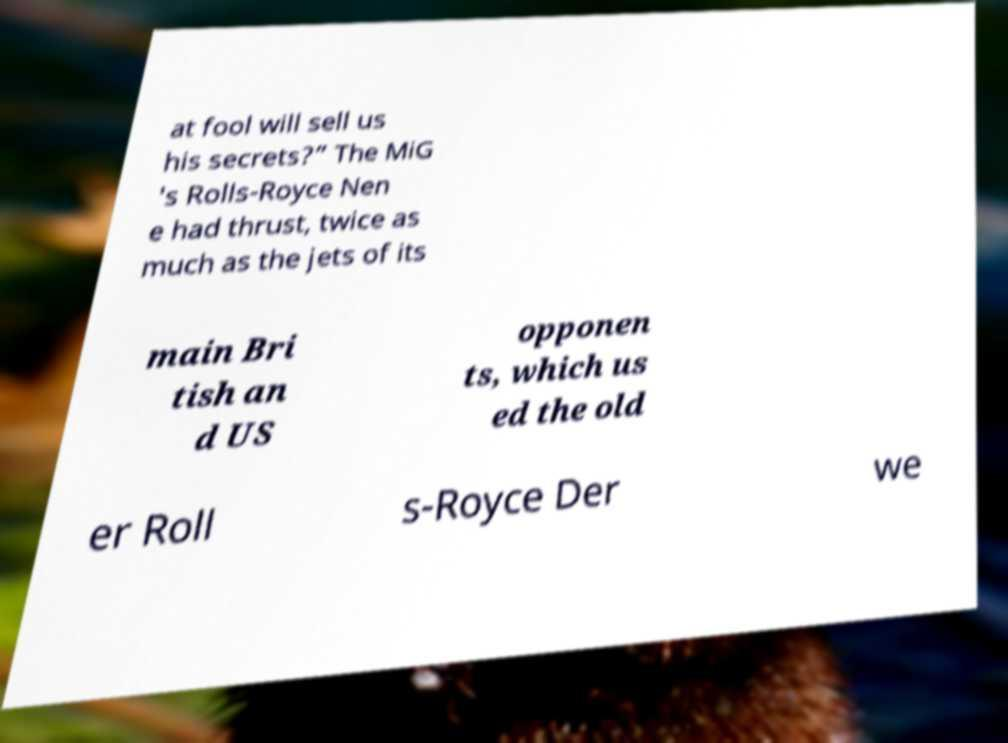Can you read and provide the text displayed in the image?This photo seems to have some interesting text. Can you extract and type it out for me? at fool will sell us his secrets?” The MiG 's Rolls-Royce Nen e had thrust, twice as much as the jets of its main Bri tish an d US opponen ts, which us ed the old er Roll s-Royce Der we 